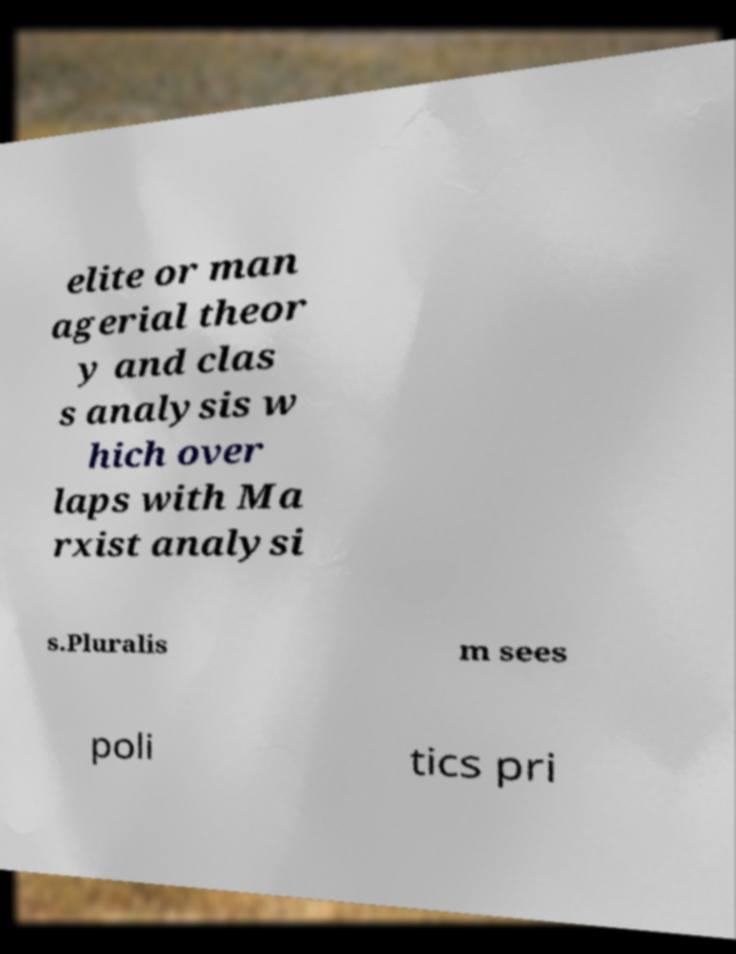For documentation purposes, I need the text within this image transcribed. Could you provide that? elite or man agerial theor y and clas s analysis w hich over laps with Ma rxist analysi s.Pluralis m sees poli tics pri 